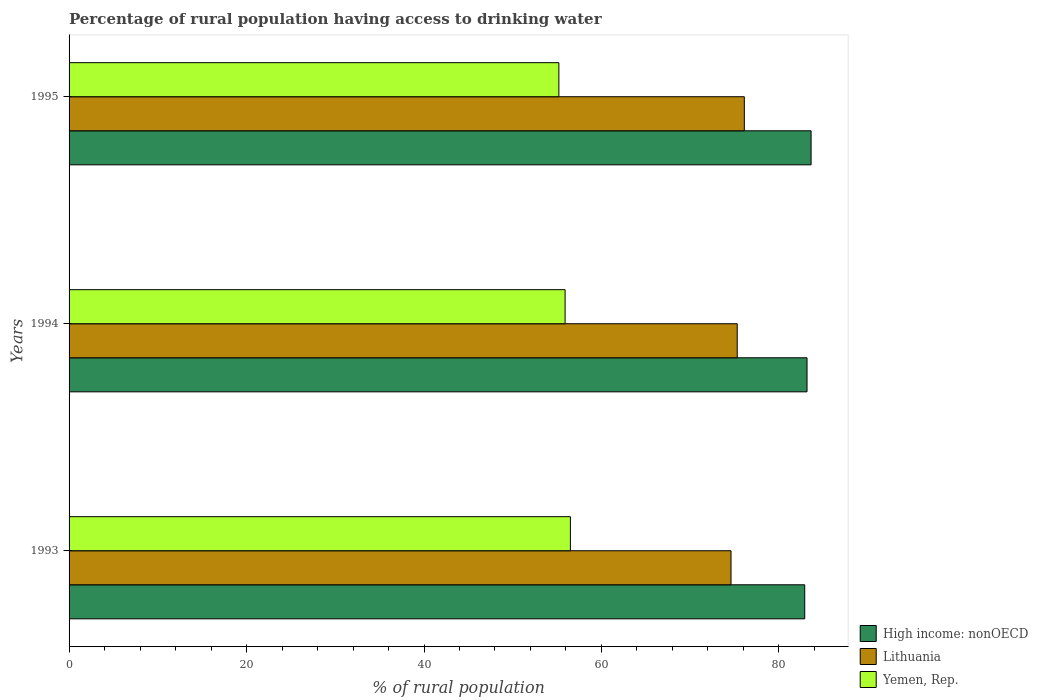How many different coloured bars are there?
Keep it short and to the point. 3. How many groups of bars are there?
Provide a succinct answer. 3. Are the number of bars on each tick of the Y-axis equal?
Ensure brevity in your answer.  Yes. In how many cases, is the number of bars for a given year not equal to the number of legend labels?
Your answer should be very brief. 0. What is the percentage of rural population having access to drinking water in Lithuania in 1995?
Give a very brief answer. 76.1. Across all years, what is the maximum percentage of rural population having access to drinking water in High income: nonOECD?
Your answer should be very brief. 83.62. Across all years, what is the minimum percentage of rural population having access to drinking water in Lithuania?
Offer a terse response. 74.6. In which year was the percentage of rural population having access to drinking water in High income: nonOECD maximum?
Provide a short and direct response. 1995. In which year was the percentage of rural population having access to drinking water in High income: nonOECD minimum?
Your response must be concise. 1993. What is the total percentage of rural population having access to drinking water in High income: nonOECD in the graph?
Your response must be concise. 249.7. What is the difference between the percentage of rural population having access to drinking water in Lithuania in 1993 and that in 1994?
Offer a terse response. -0.7. What is the difference between the percentage of rural population having access to drinking water in Lithuania in 1993 and the percentage of rural population having access to drinking water in High income: nonOECD in 1994?
Your answer should be compact. -8.57. What is the average percentage of rural population having access to drinking water in Yemen, Rep. per year?
Your response must be concise. 55.87. In the year 1994, what is the difference between the percentage of rural population having access to drinking water in High income: nonOECD and percentage of rural population having access to drinking water in Lithuania?
Keep it short and to the point. 7.87. What is the ratio of the percentage of rural population having access to drinking water in Lithuania in 1993 to that in 1994?
Offer a very short reply. 0.99. Is the percentage of rural population having access to drinking water in Yemen, Rep. in 1993 less than that in 1994?
Offer a very short reply. No. What is the difference between the highest and the second highest percentage of rural population having access to drinking water in Yemen, Rep.?
Provide a succinct answer. 0.6. What is the difference between the highest and the lowest percentage of rural population having access to drinking water in Yemen, Rep.?
Ensure brevity in your answer.  1.3. In how many years, is the percentage of rural population having access to drinking water in Lithuania greater than the average percentage of rural population having access to drinking water in Lithuania taken over all years?
Ensure brevity in your answer.  1. Is the sum of the percentage of rural population having access to drinking water in Yemen, Rep. in 1993 and 1995 greater than the maximum percentage of rural population having access to drinking water in High income: nonOECD across all years?
Your answer should be compact. Yes. What does the 1st bar from the top in 1995 represents?
Give a very brief answer. Yemen, Rep. What does the 2nd bar from the bottom in 1995 represents?
Your response must be concise. Lithuania. Is it the case that in every year, the sum of the percentage of rural population having access to drinking water in Yemen, Rep. and percentage of rural population having access to drinking water in Lithuania is greater than the percentage of rural population having access to drinking water in High income: nonOECD?
Give a very brief answer. Yes. What is the difference between two consecutive major ticks on the X-axis?
Offer a very short reply. 20. Does the graph contain any zero values?
Provide a short and direct response. No. What is the title of the graph?
Keep it short and to the point. Percentage of rural population having access to drinking water. What is the label or title of the X-axis?
Provide a succinct answer. % of rural population. What is the label or title of the Y-axis?
Make the answer very short. Years. What is the % of rural population of High income: nonOECD in 1993?
Keep it short and to the point. 82.91. What is the % of rural population of Lithuania in 1993?
Your answer should be very brief. 74.6. What is the % of rural population of Yemen, Rep. in 1993?
Make the answer very short. 56.5. What is the % of rural population in High income: nonOECD in 1994?
Your response must be concise. 83.17. What is the % of rural population in Lithuania in 1994?
Your response must be concise. 75.3. What is the % of rural population in Yemen, Rep. in 1994?
Give a very brief answer. 55.9. What is the % of rural population of High income: nonOECD in 1995?
Provide a succinct answer. 83.62. What is the % of rural population of Lithuania in 1995?
Ensure brevity in your answer.  76.1. What is the % of rural population in Yemen, Rep. in 1995?
Offer a terse response. 55.2. Across all years, what is the maximum % of rural population of High income: nonOECD?
Make the answer very short. 83.62. Across all years, what is the maximum % of rural population of Lithuania?
Your answer should be compact. 76.1. Across all years, what is the maximum % of rural population of Yemen, Rep.?
Give a very brief answer. 56.5. Across all years, what is the minimum % of rural population in High income: nonOECD?
Provide a short and direct response. 82.91. Across all years, what is the minimum % of rural population in Lithuania?
Offer a very short reply. 74.6. Across all years, what is the minimum % of rural population in Yemen, Rep.?
Your answer should be compact. 55.2. What is the total % of rural population of High income: nonOECD in the graph?
Offer a terse response. 249.7. What is the total % of rural population in Lithuania in the graph?
Keep it short and to the point. 226. What is the total % of rural population of Yemen, Rep. in the graph?
Your response must be concise. 167.6. What is the difference between the % of rural population in High income: nonOECD in 1993 and that in 1994?
Offer a terse response. -0.26. What is the difference between the % of rural population in Yemen, Rep. in 1993 and that in 1994?
Keep it short and to the point. 0.6. What is the difference between the % of rural population in High income: nonOECD in 1993 and that in 1995?
Your answer should be compact. -0.72. What is the difference between the % of rural population of High income: nonOECD in 1994 and that in 1995?
Ensure brevity in your answer.  -0.46. What is the difference between the % of rural population of Yemen, Rep. in 1994 and that in 1995?
Your answer should be very brief. 0.7. What is the difference between the % of rural population in High income: nonOECD in 1993 and the % of rural population in Lithuania in 1994?
Give a very brief answer. 7.61. What is the difference between the % of rural population in High income: nonOECD in 1993 and the % of rural population in Yemen, Rep. in 1994?
Provide a short and direct response. 27.01. What is the difference between the % of rural population of Lithuania in 1993 and the % of rural population of Yemen, Rep. in 1994?
Offer a very short reply. 18.7. What is the difference between the % of rural population of High income: nonOECD in 1993 and the % of rural population of Lithuania in 1995?
Your answer should be very brief. 6.81. What is the difference between the % of rural population in High income: nonOECD in 1993 and the % of rural population in Yemen, Rep. in 1995?
Offer a terse response. 27.71. What is the difference between the % of rural population of Lithuania in 1993 and the % of rural population of Yemen, Rep. in 1995?
Give a very brief answer. 19.4. What is the difference between the % of rural population in High income: nonOECD in 1994 and the % of rural population in Lithuania in 1995?
Make the answer very short. 7.07. What is the difference between the % of rural population in High income: nonOECD in 1994 and the % of rural population in Yemen, Rep. in 1995?
Provide a short and direct response. 27.97. What is the difference between the % of rural population of Lithuania in 1994 and the % of rural population of Yemen, Rep. in 1995?
Ensure brevity in your answer.  20.1. What is the average % of rural population in High income: nonOECD per year?
Your answer should be very brief. 83.23. What is the average % of rural population in Lithuania per year?
Offer a very short reply. 75.33. What is the average % of rural population of Yemen, Rep. per year?
Your answer should be compact. 55.87. In the year 1993, what is the difference between the % of rural population of High income: nonOECD and % of rural population of Lithuania?
Provide a short and direct response. 8.31. In the year 1993, what is the difference between the % of rural population in High income: nonOECD and % of rural population in Yemen, Rep.?
Ensure brevity in your answer.  26.41. In the year 1993, what is the difference between the % of rural population in Lithuania and % of rural population in Yemen, Rep.?
Offer a terse response. 18.1. In the year 1994, what is the difference between the % of rural population of High income: nonOECD and % of rural population of Lithuania?
Make the answer very short. 7.87. In the year 1994, what is the difference between the % of rural population of High income: nonOECD and % of rural population of Yemen, Rep.?
Offer a terse response. 27.27. In the year 1995, what is the difference between the % of rural population of High income: nonOECD and % of rural population of Lithuania?
Your answer should be compact. 7.52. In the year 1995, what is the difference between the % of rural population in High income: nonOECD and % of rural population in Yemen, Rep.?
Your answer should be very brief. 28.42. In the year 1995, what is the difference between the % of rural population in Lithuania and % of rural population in Yemen, Rep.?
Give a very brief answer. 20.9. What is the ratio of the % of rural population of High income: nonOECD in 1993 to that in 1994?
Offer a very short reply. 1. What is the ratio of the % of rural population in Lithuania in 1993 to that in 1994?
Your answer should be compact. 0.99. What is the ratio of the % of rural population of Yemen, Rep. in 1993 to that in 1994?
Give a very brief answer. 1.01. What is the ratio of the % of rural population of Lithuania in 1993 to that in 1995?
Make the answer very short. 0.98. What is the ratio of the % of rural population of Yemen, Rep. in 1993 to that in 1995?
Your answer should be compact. 1.02. What is the ratio of the % of rural population in Yemen, Rep. in 1994 to that in 1995?
Your response must be concise. 1.01. What is the difference between the highest and the second highest % of rural population in High income: nonOECD?
Provide a succinct answer. 0.46. What is the difference between the highest and the second highest % of rural population of Lithuania?
Offer a very short reply. 0.8. What is the difference between the highest and the lowest % of rural population of High income: nonOECD?
Your answer should be very brief. 0.72. What is the difference between the highest and the lowest % of rural population of Yemen, Rep.?
Ensure brevity in your answer.  1.3. 